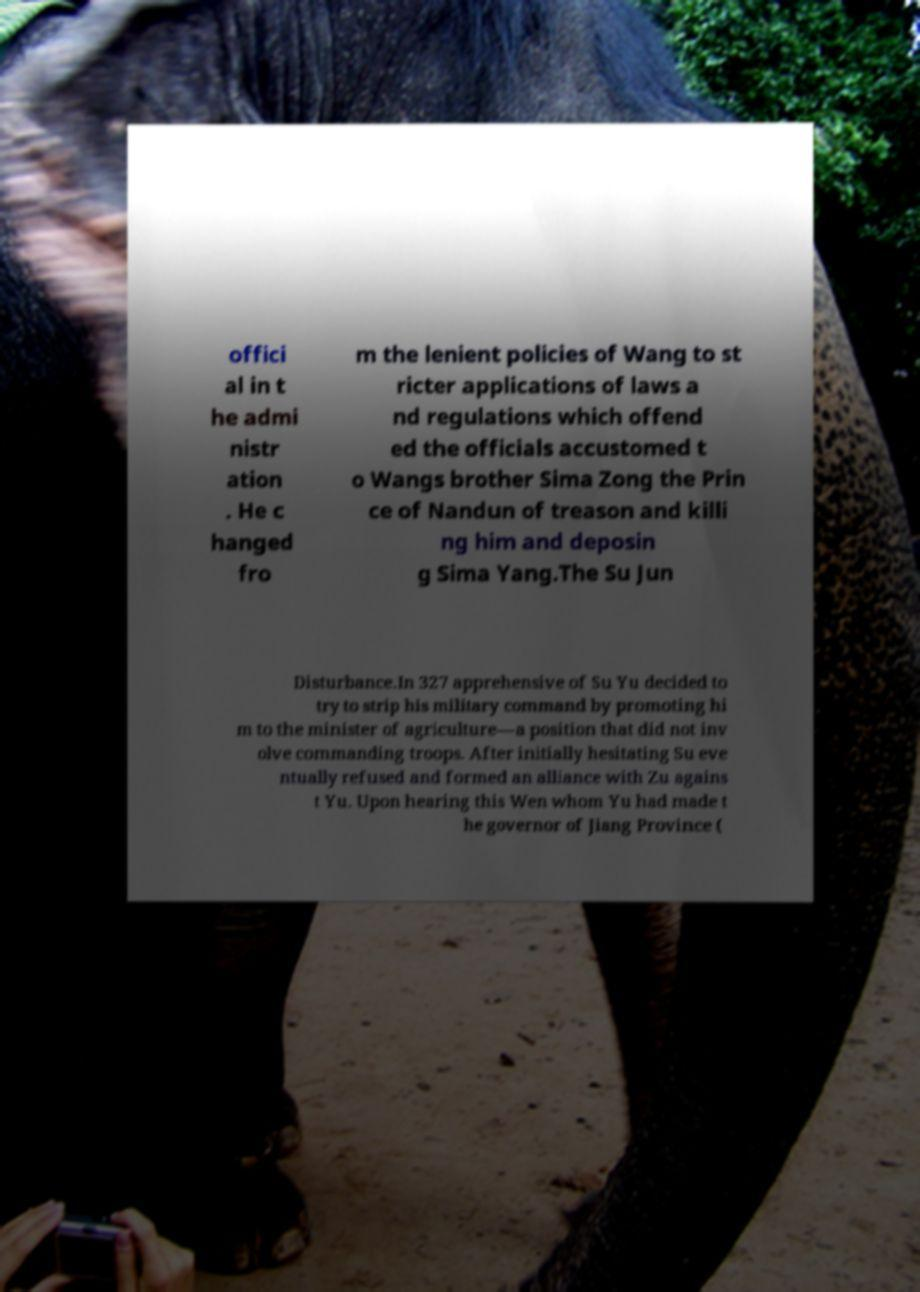There's text embedded in this image that I need extracted. Can you transcribe it verbatim? offici al in t he admi nistr ation . He c hanged fro m the lenient policies of Wang to st ricter applications of laws a nd regulations which offend ed the officials accustomed t o Wangs brother Sima Zong the Prin ce of Nandun of treason and killi ng him and deposin g Sima Yang.The Su Jun Disturbance.In 327 apprehensive of Su Yu decided to try to strip his military command by promoting hi m to the minister of agriculture—a position that did not inv olve commanding troops. After initially hesitating Su eve ntually refused and formed an alliance with Zu agains t Yu. Upon hearing this Wen whom Yu had made t he governor of Jiang Province ( 